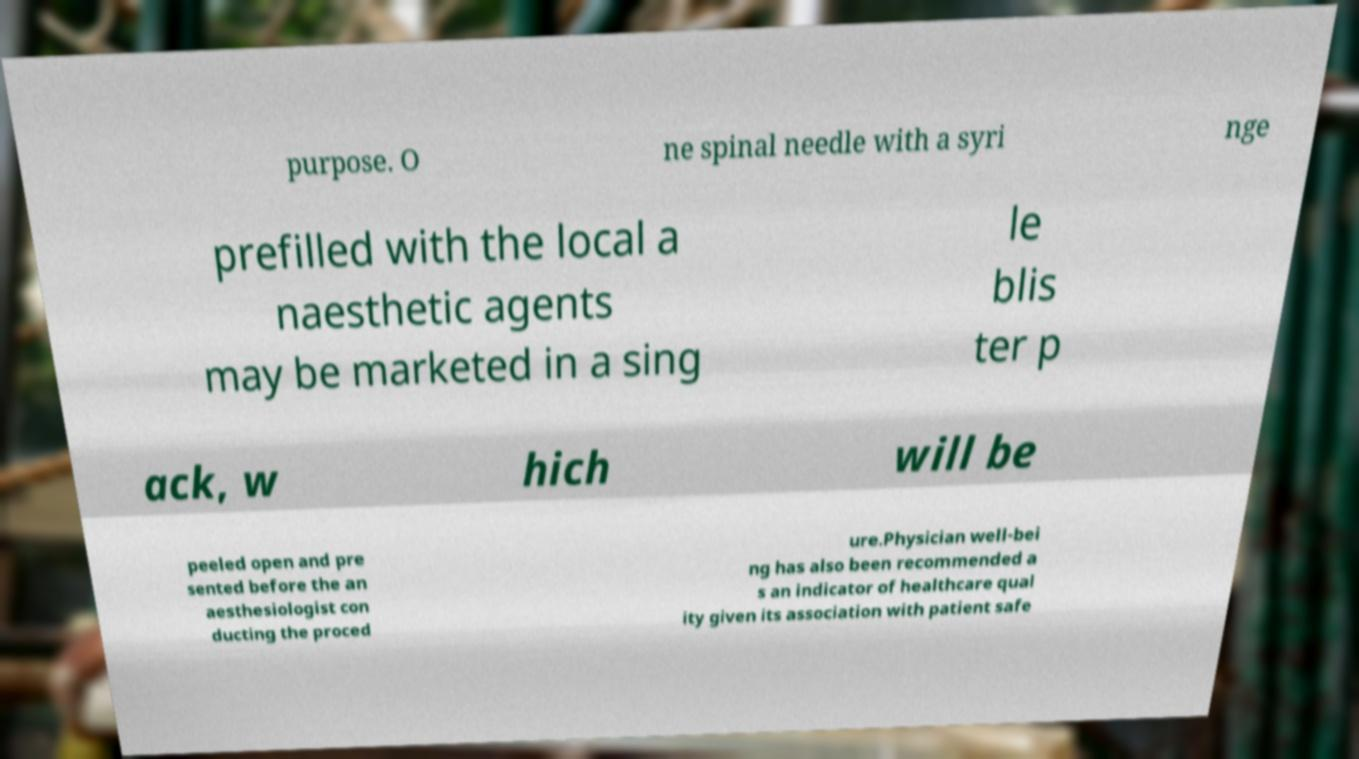Please identify and transcribe the text found in this image. purpose. O ne spinal needle with a syri nge prefilled with the local a naesthetic agents may be marketed in a sing le blis ter p ack, w hich will be peeled open and pre sented before the an aesthesiologist con ducting the proced ure.Physician well-bei ng has also been recommended a s an indicator of healthcare qual ity given its association with patient safe 